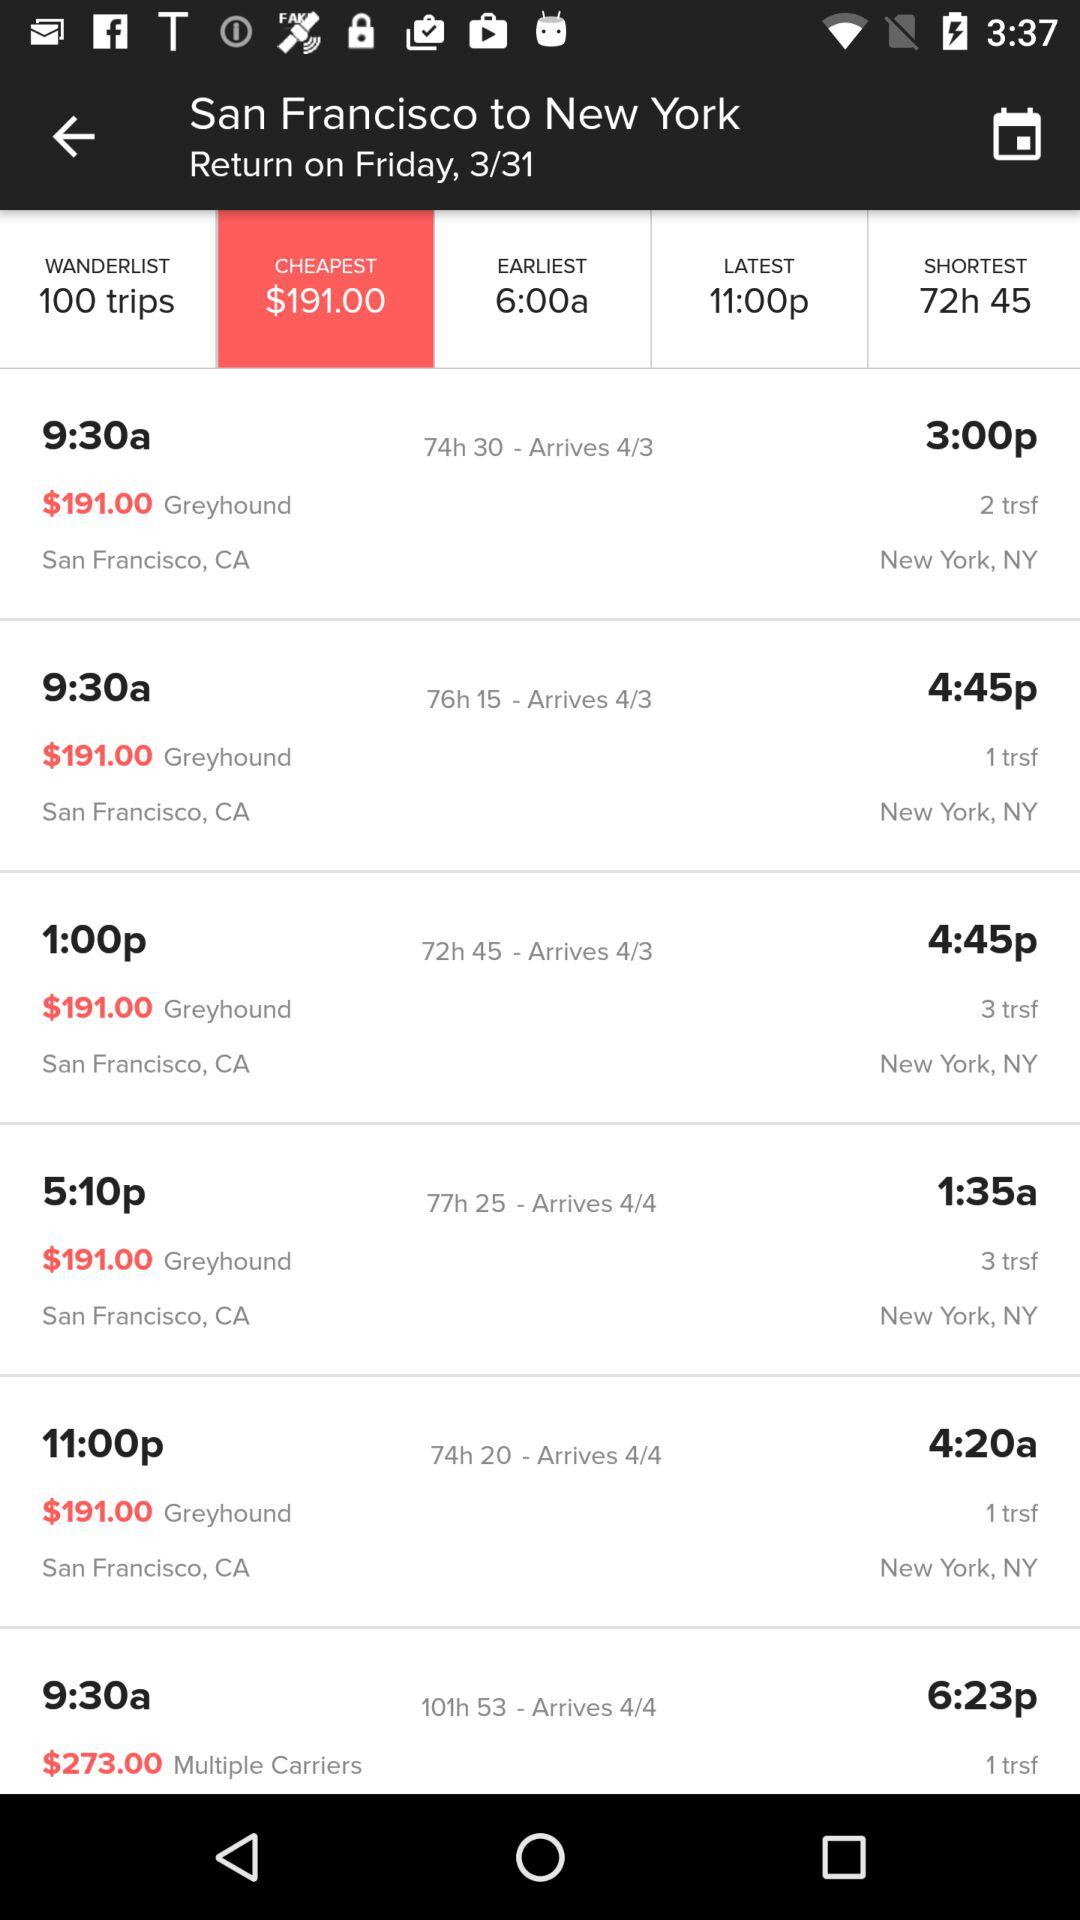What is the return date? The return date is Friday, March 31st. 